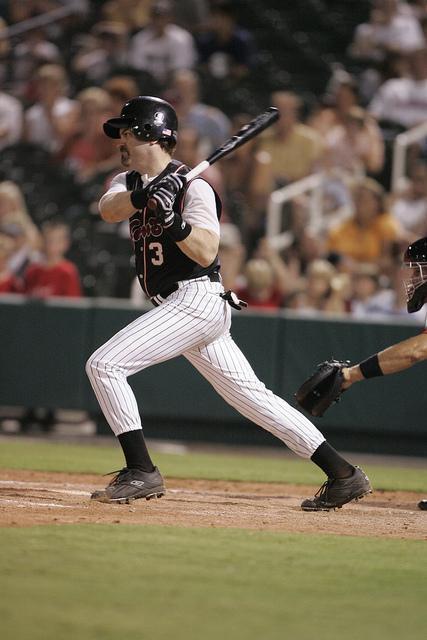How many people are there?
Give a very brief answer. 10. 